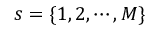<formula> <loc_0><loc_0><loc_500><loc_500>s = \{ 1 , 2 , \cdots , M \}</formula> 